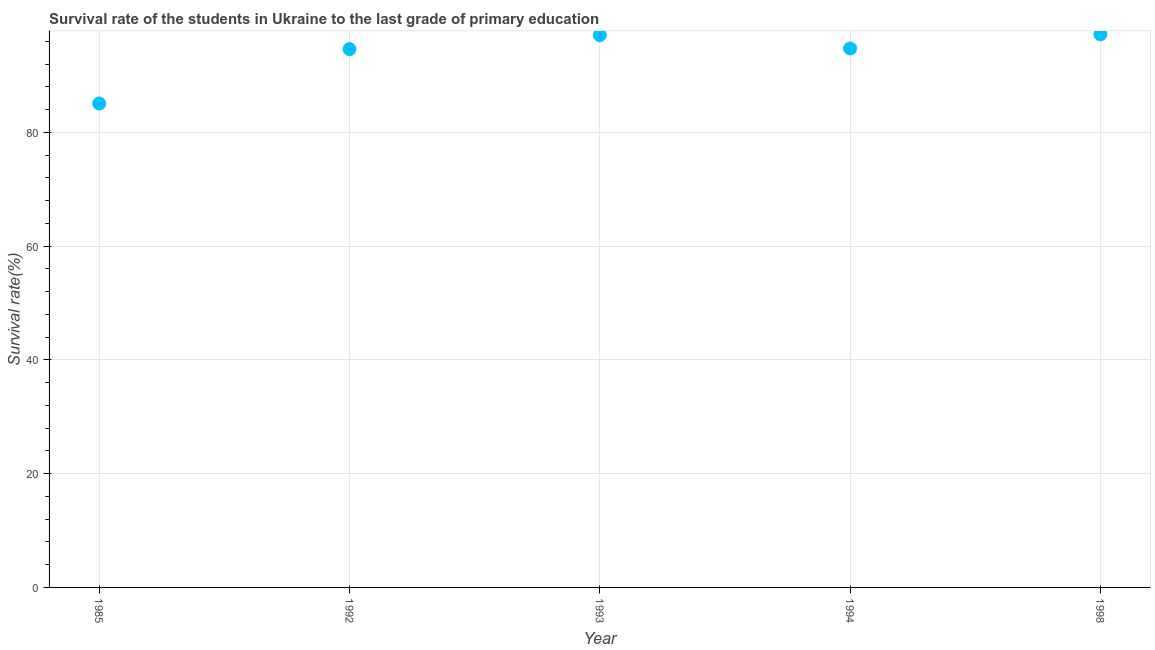What is the survival rate in primary education in 1993?
Ensure brevity in your answer.  97.1. Across all years, what is the maximum survival rate in primary education?
Give a very brief answer. 97.25. Across all years, what is the minimum survival rate in primary education?
Provide a succinct answer. 85.07. In which year was the survival rate in primary education minimum?
Ensure brevity in your answer.  1985. What is the sum of the survival rate in primary education?
Your response must be concise. 468.81. What is the difference between the survival rate in primary education in 1992 and 1998?
Your answer should be very brief. -2.61. What is the average survival rate in primary education per year?
Provide a succinct answer. 93.76. What is the median survival rate in primary education?
Your answer should be very brief. 94.75. In how many years, is the survival rate in primary education greater than 84 %?
Your answer should be very brief. 5. Do a majority of the years between 1993 and 1994 (inclusive) have survival rate in primary education greater than 8 %?
Offer a terse response. Yes. What is the ratio of the survival rate in primary education in 1985 to that in 1993?
Give a very brief answer. 0.88. Is the survival rate in primary education in 1992 less than that in 1998?
Your answer should be very brief. Yes. Is the difference between the survival rate in primary education in 1985 and 1994 greater than the difference between any two years?
Your answer should be compact. No. What is the difference between the highest and the second highest survival rate in primary education?
Your answer should be very brief. 0.15. Is the sum of the survival rate in primary education in 1993 and 1994 greater than the maximum survival rate in primary education across all years?
Provide a short and direct response. Yes. What is the difference between the highest and the lowest survival rate in primary education?
Keep it short and to the point. 12.17. In how many years, is the survival rate in primary education greater than the average survival rate in primary education taken over all years?
Keep it short and to the point. 4. How many dotlines are there?
Provide a short and direct response. 1. What is the difference between two consecutive major ticks on the Y-axis?
Your response must be concise. 20. Are the values on the major ticks of Y-axis written in scientific E-notation?
Your answer should be very brief. No. Does the graph contain any zero values?
Offer a terse response. No. What is the title of the graph?
Give a very brief answer. Survival rate of the students in Ukraine to the last grade of primary education. What is the label or title of the X-axis?
Provide a short and direct response. Year. What is the label or title of the Y-axis?
Provide a succinct answer. Survival rate(%). What is the Survival rate(%) in 1985?
Your answer should be compact. 85.07. What is the Survival rate(%) in 1992?
Give a very brief answer. 94.64. What is the Survival rate(%) in 1993?
Ensure brevity in your answer.  97.1. What is the Survival rate(%) in 1994?
Make the answer very short. 94.75. What is the Survival rate(%) in 1998?
Your answer should be very brief. 97.25. What is the difference between the Survival rate(%) in 1985 and 1992?
Give a very brief answer. -9.57. What is the difference between the Survival rate(%) in 1985 and 1993?
Make the answer very short. -12.02. What is the difference between the Survival rate(%) in 1985 and 1994?
Provide a short and direct response. -9.68. What is the difference between the Survival rate(%) in 1985 and 1998?
Your answer should be compact. -12.17. What is the difference between the Survival rate(%) in 1992 and 1993?
Give a very brief answer. -2.46. What is the difference between the Survival rate(%) in 1992 and 1994?
Provide a succinct answer. -0.11. What is the difference between the Survival rate(%) in 1992 and 1998?
Keep it short and to the point. -2.61. What is the difference between the Survival rate(%) in 1993 and 1994?
Your answer should be very brief. 2.34. What is the difference between the Survival rate(%) in 1993 and 1998?
Your answer should be very brief. -0.15. What is the difference between the Survival rate(%) in 1994 and 1998?
Offer a terse response. -2.49. What is the ratio of the Survival rate(%) in 1985 to that in 1992?
Ensure brevity in your answer.  0.9. What is the ratio of the Survival rate(%) in 1985 to that in 1993?
Give a very brief answer. 0.88. What is the ratio of the Survival rate(%) in 1985 to that in 1994?
Keep it short and to the point. 0.9. What is the ratio of the Survival rate(%) in 1992 to that in 1994?
Provide a short and direct response. 1. What is the ratio of the Survival rate(%) in 1992 to that in 1998?
Keep it short and to the point. 0.97. What is the ratio of the Survival rate(%) in 1993 to that in 1998?
Keep it short and to the point. 1. 